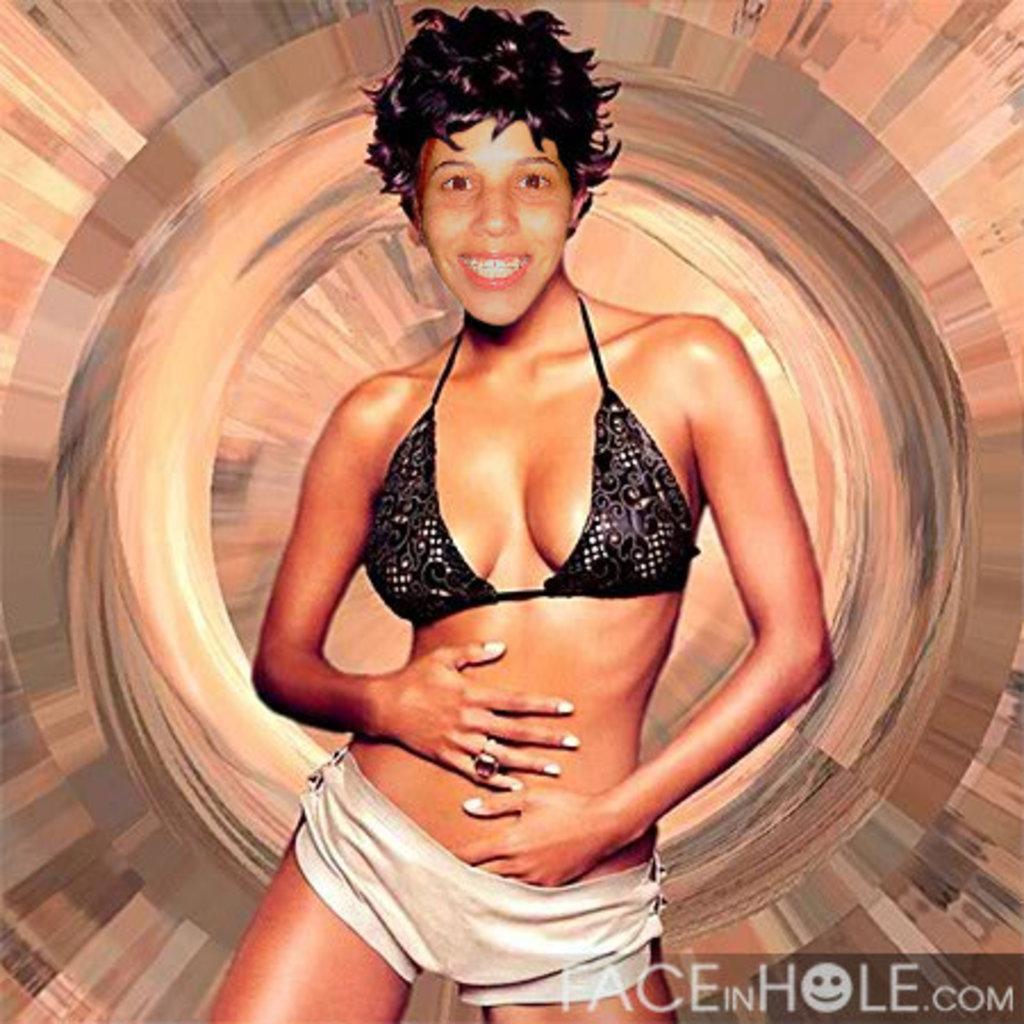Could you give a brief overview of what you see in this image? In this picture there is a woman standing. This picture is an edited picture. In the bottom right there is a text. 